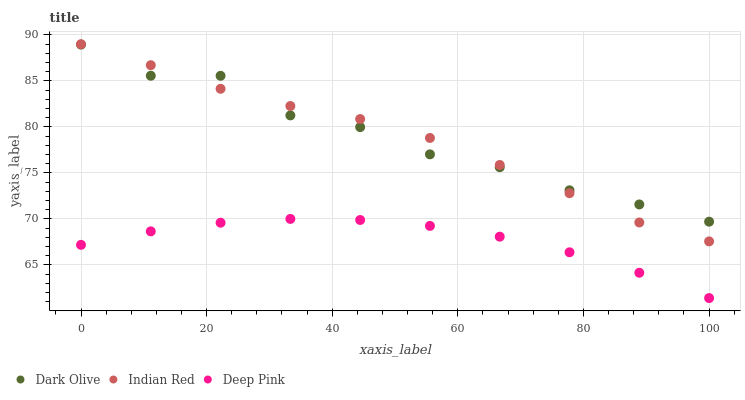Does Deep Pink have the minimum area under the curve?
Answer yes or no. Yes. Does Indian Red have the maximum area under the curve?
Answer yes or no. Yes. Does Indian Red have the minimum area under the curve?
Answer yes or no. No. Does Deep Pink have the maximum area under the curve?
Answer yes or no. No. Is Deep Pink the smoothest?
Answer yes or no. Yes. Is Dark Olive the roughest?
Answer yes or no. Yes. Is Indian Red the smoothest?
Answer yes or no. No. Is Indian Red the roughest?
Answer yes or no. No. Does Deep Pink have the lowest value?
Answer yes or no. Yes. Does Indian Red have the lowest value?
Answer yes or no. No. Does Indian Red have the highest value?
Answer yes or no. Yes. Does Deep Pink have the highest value?
Answer yes or no. No. Is Deep Pink less than Dark Olive?
Answer yes or no. Yes. Is Dark Olive greater than Deep Pink?
Answer yes or no. Yes. Does Dark Olive intersect Indian Red?
Answer yes or no. Yes. Is Dark Olive less than Indian Red?
Answer yes or no. No. Is Dark Olive greater than Indian Red?
Answer yes or no. No. Does Deep Pink intersect Dark Olive?
Answer yes or no. No. 